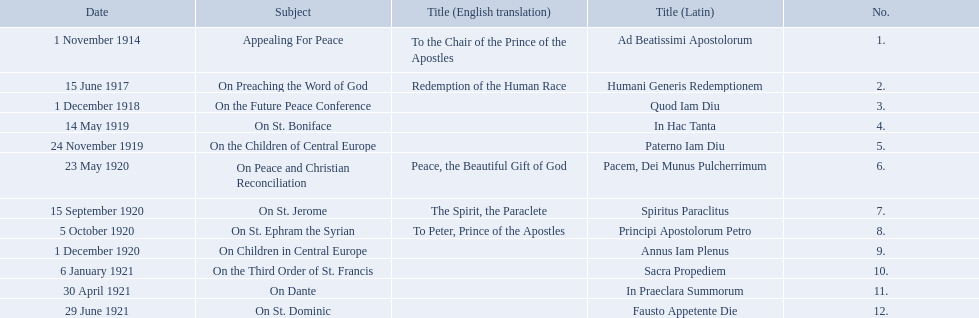What are all the subjects? Appealing For Peace, On Preaching the Word of God, On the Future Peace Conference, On St. Boniface, On the Children of Central Europe, On Peace and Christian Reconciliation, On St. Jerome, On St. Ephram the Syrian, On Children in Central Europe, On the Third Order of St. Francis, On Dante, On St. Dominic. Which occurred in 1920? On Peace and Christian Reconciliation, On St. Jerome, On St. Ephram the Syrian, On Children in Central Europe. Which occurred in may of that year? On Peace and Christian Reconciliation. 